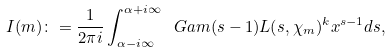Convert formula to latex. <formula><loc_0><loc_0><loc_500><loc_500>I ( m ) \colon = \frac { 1 } { 2 \pi i } \int _ { \alpha - i \infty } ^ { \alpha + i \infty } \ G a m ( s - 1 ) L ( s , \chi _ { m } ) ^ { k } x ^ { s - 1 } d s ,</formula> 